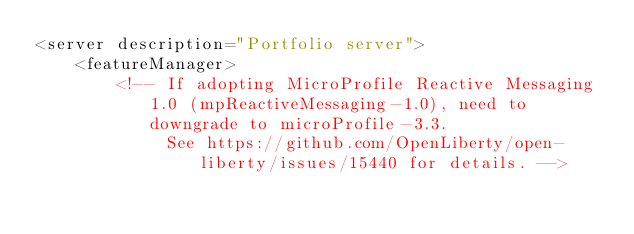Convert code to text. <code><loc_0><loc_0><loc_500><loc_500><_XML_><server description="Portfolio server">
    <featureManager>
        <!-- If adopting MicroProfile Reactive Messaging 1.0 (mpReactiveMessaging-1.0), need to downgrade to microProfile-3.3.
             See https://github.com/OpenLiberty/open-liberty/issues/15440 for details. --></code> 